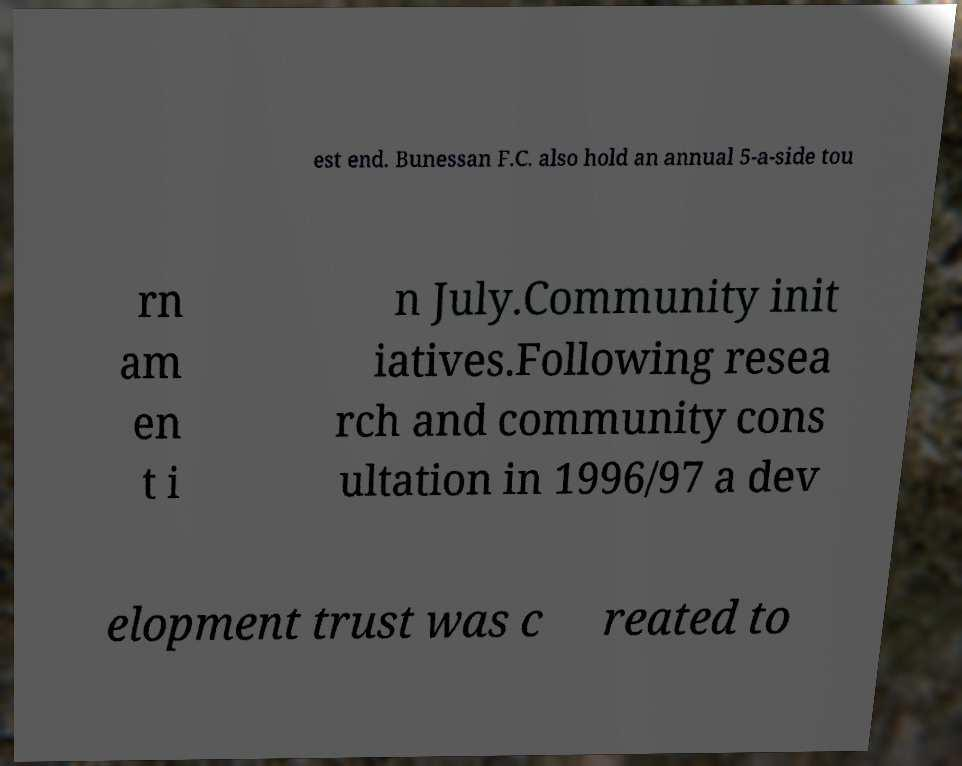Could you assist in decoding the text presented in this image and type it out clearly? est end. Bunessan F.C. also hold an annual 5-a-side tou rn am en t i n July.Community init iatives.Following resea rch and community cons ultation in 1996/97 a dev elopment trust was c reated to 